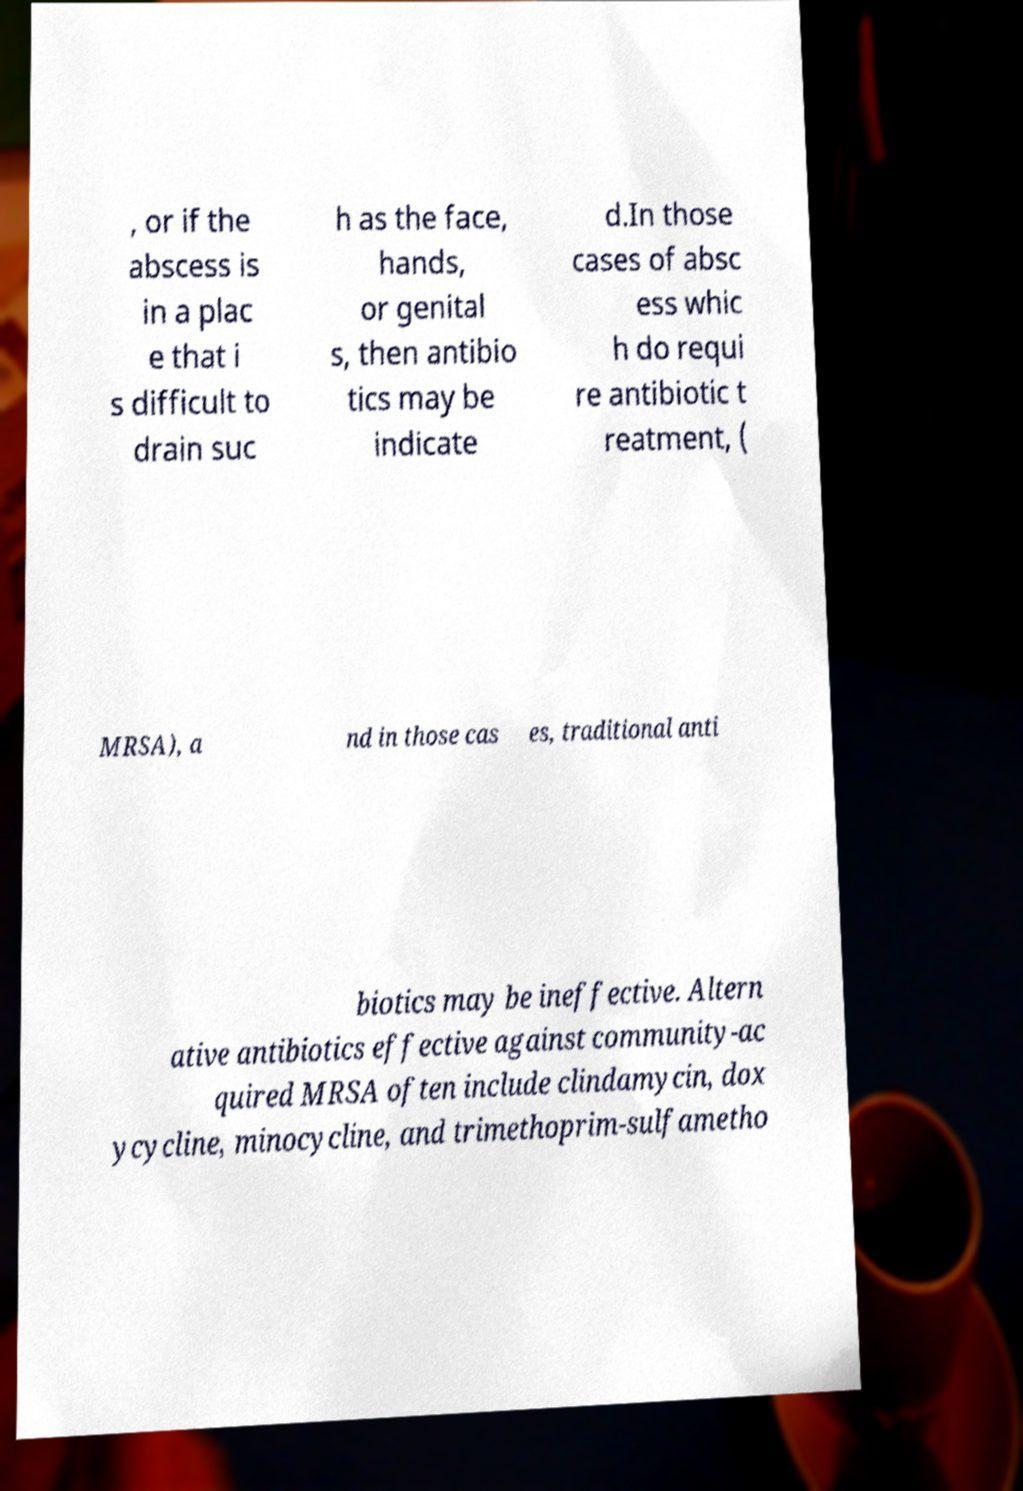Can you accurately transcribe the text from the provided image for me? , or if the abscess is in a plac e that i s difficult to drain suc h as the face, hands, or genital s, then antibio tics may be indicate d.In those cases of absc ess whic h do requi re antibiotic t reatment, ( MRSA), a nd in those cas es, traditional anti biotics may be ineffective. Altern ative antibiotics effective against community-ac quired MRSA often include clindamycin, dox ycycline, minocycline, and trimethoprim-sulfametho 